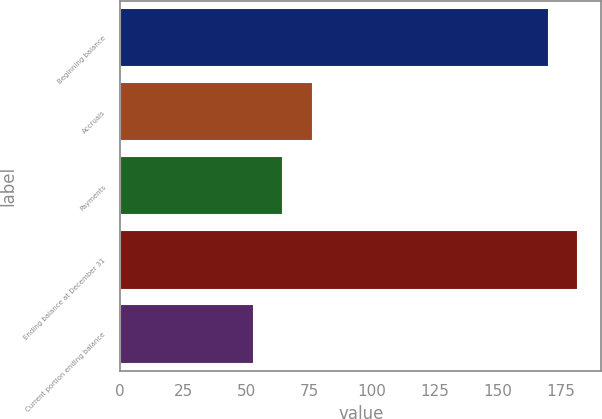<chart> <loc_0><loc_0><loc_500><loc_500><bar_chart><fcel>Beginning balance<fcel>Accruals<fcel>Payments<fcel>Ending balance at December 31<fcel>Current portion ending balance<nl><fcel>170<fcel>76.6<fcel>64.8<fcel>181.8<fcel>53<nl></chart> 